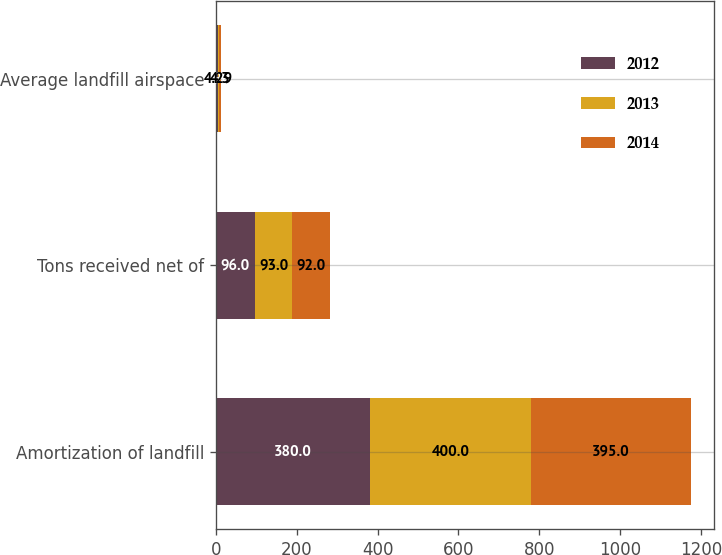Convert chart. <chart><loc_0><loc_0><loc_500><loc_500><stacked_bar_chart><ecel><fcel>Amortization of landfill<fcel>Tons received net of<fcel>Average landfill airspace<nl><fcel>2012<fcel>380<fcel>96<fcel>3.96<nl><fcel>2013<fcel>400<fcel>93<fcel>4.29<nl><fcel>2014<fcel>395<fcel>92<fcel>4.3<nl></chart> 